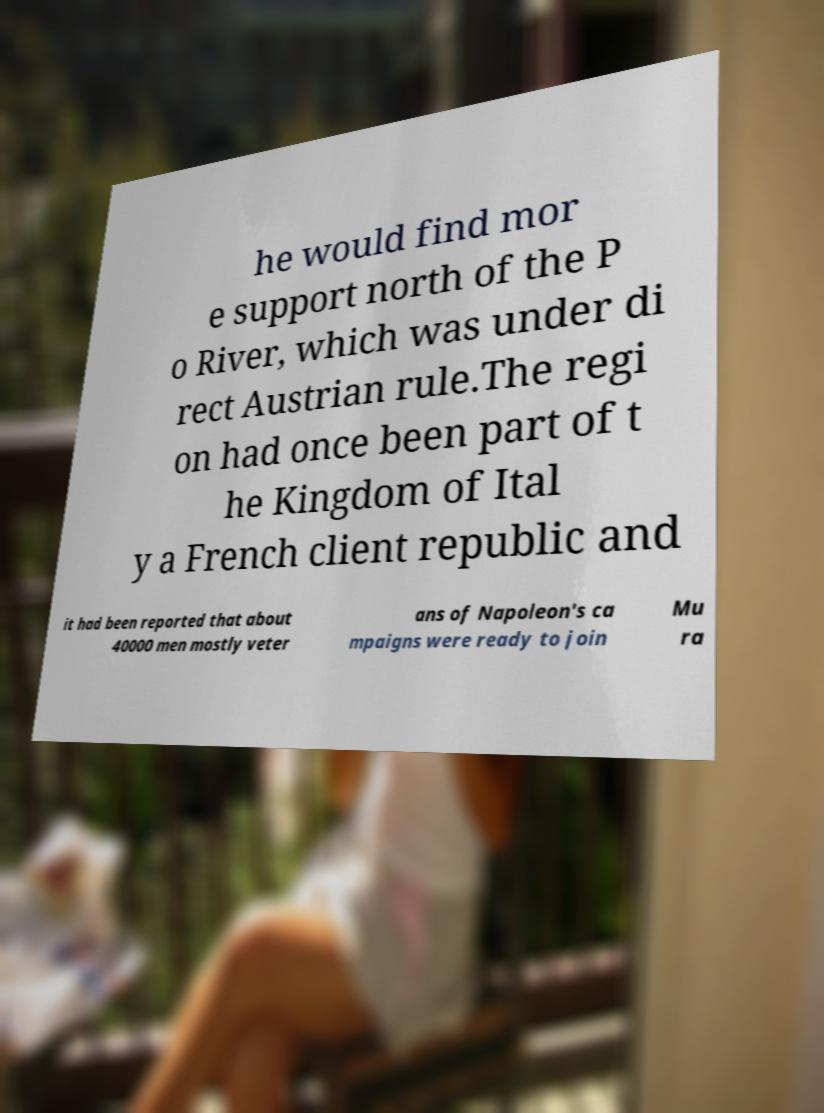What messages or text are displayed in this image? I need them in a readable, typed format. he would find mor e support north of the P o River, which was under di rect Austrian rule.The regi on had once been part of t he Kingdom of Ital y a French client republic and it had been reported that about 40000 men mostly veter ans of Napoleon's ca mpaigns were ready to join Mu ra 